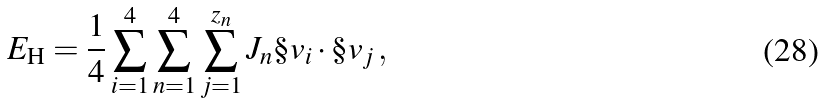Convert formula to latex. <formula><loc_0><loc_0><loc_500><loc_500>E _ { \text {H} } = \frac { 1 } { 4 } \sum _ { i = 1 } ^ { 4 } \sum _ { n = 1 } ^ { 4 } \sum _ { j = 1 } ^ { z _ { n } } J _ { n } \S v _ { i } \cdot \S v _ { j } \, ,</formula> 